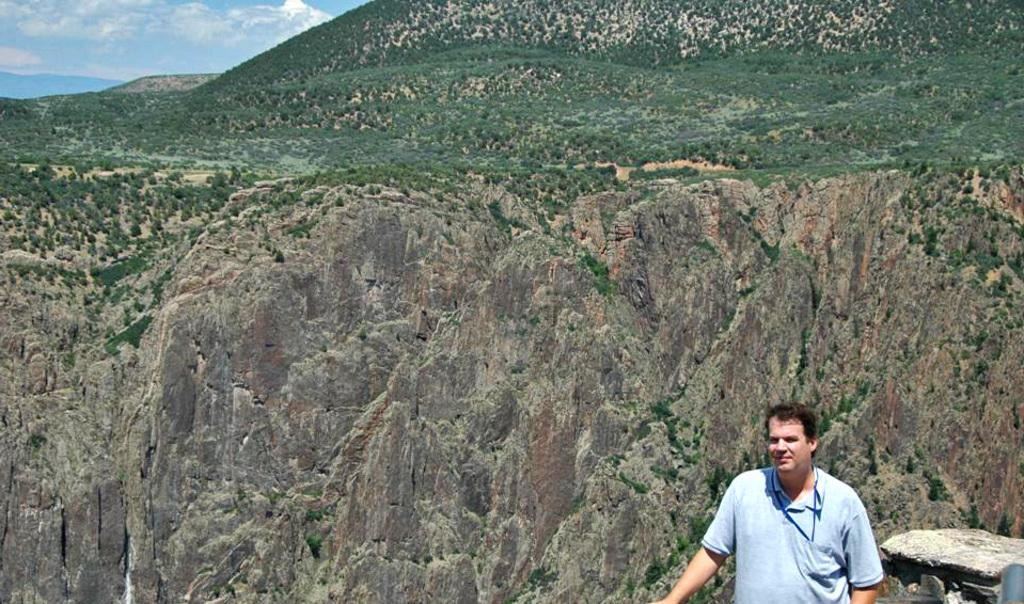What is the main subject in the image? There is a person standing in the image. What object can be seen near the person? There is a stone in the image. What can be seen in the distance behind the person? There is a mountain in the background of the image. What type of vegetation is present on the mountain? There are plants on the mountain. How would you describe the sky in the image? The sky is cloudy at the top of the image. What type of card is the person holding in the image? There is no card present in the image; the person is not holding anything. 